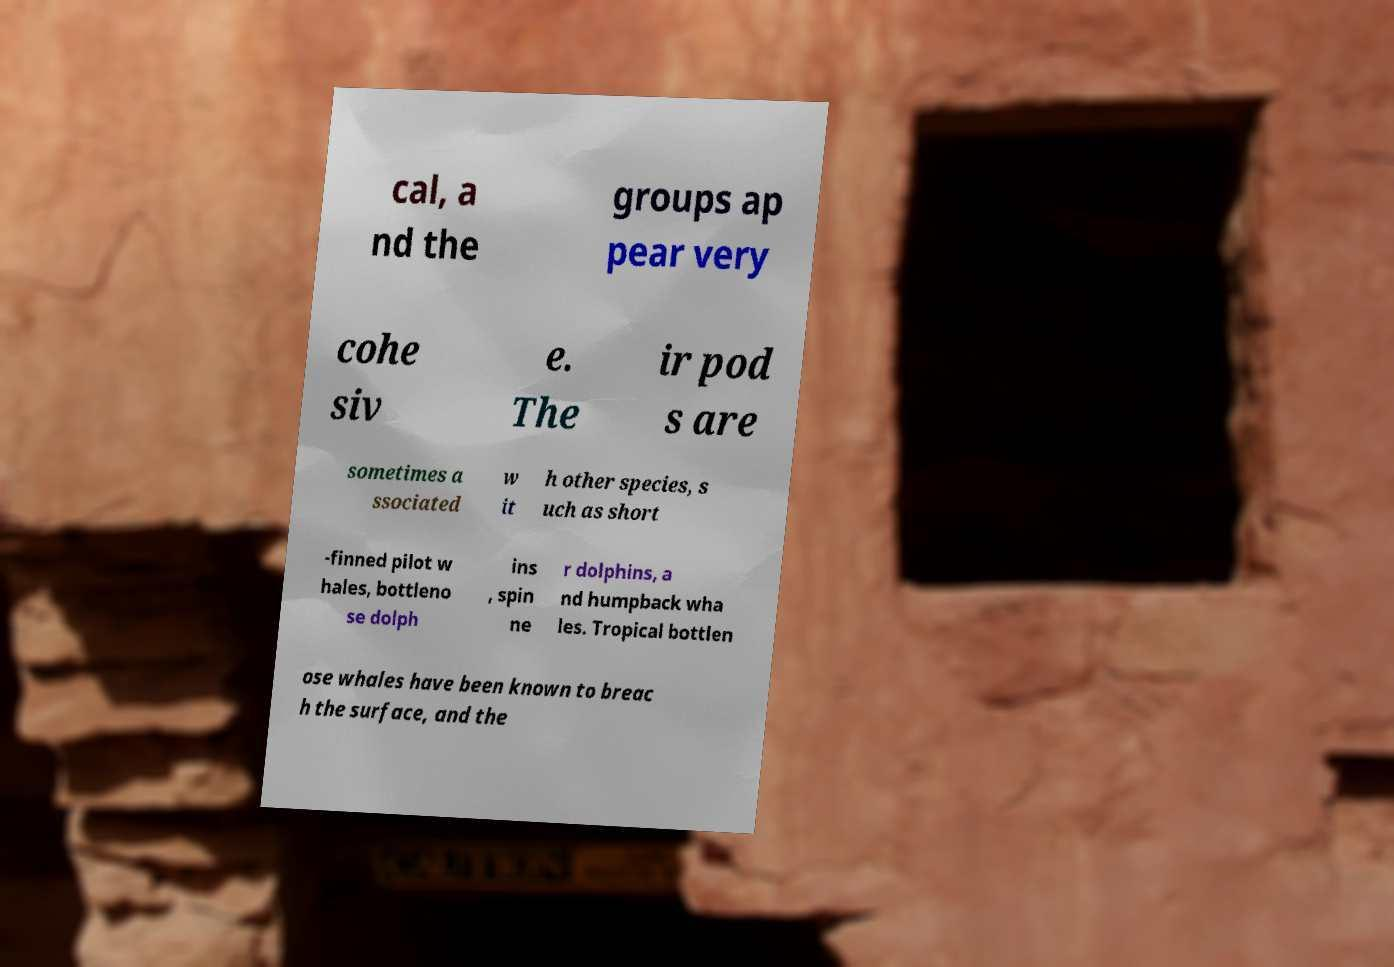Please identify and transcribe the text found in this image. cal, a nd the groups ap pear very cohe siv e. The ir pod s are sometimes a ssociated w it h other species, s uch as short -finned pilot w hales, bottleno se dolph ins , spin ne r dolphins, a nd humpback wha les. Tropical bottlen ose whales have been known to breac h the surface, and the 